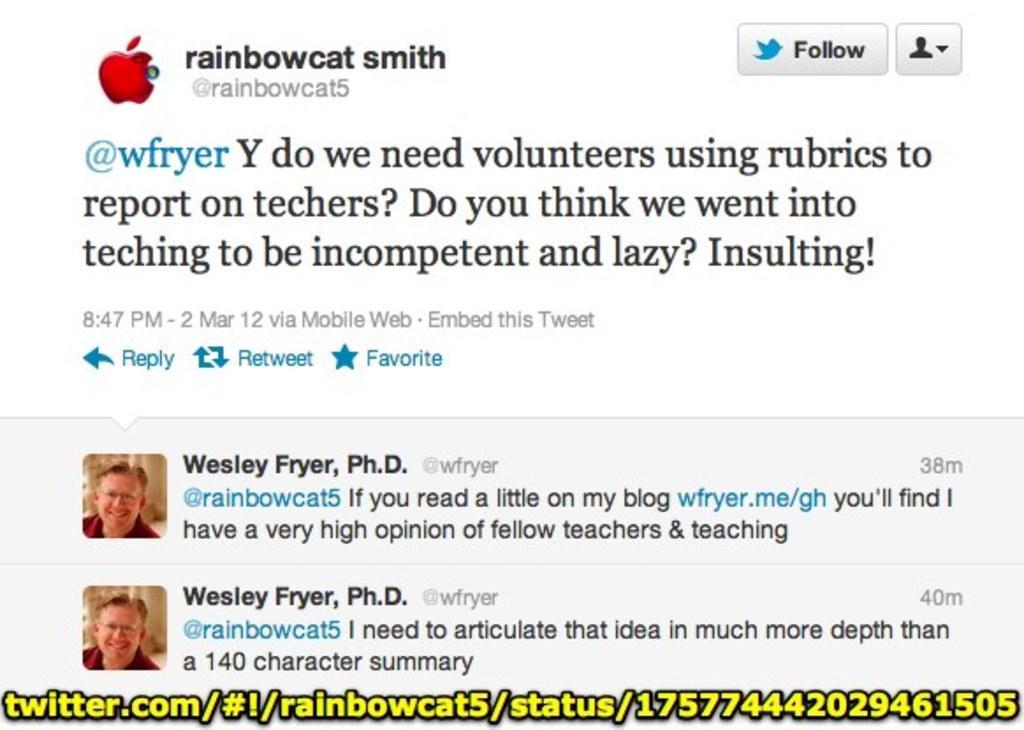In one or two sentences, can you explain what this image depicts? In this image I can see the screenshot. In this screenshot I can see the text. To the left I can see the person's photo and the apple symbol can be seen. 